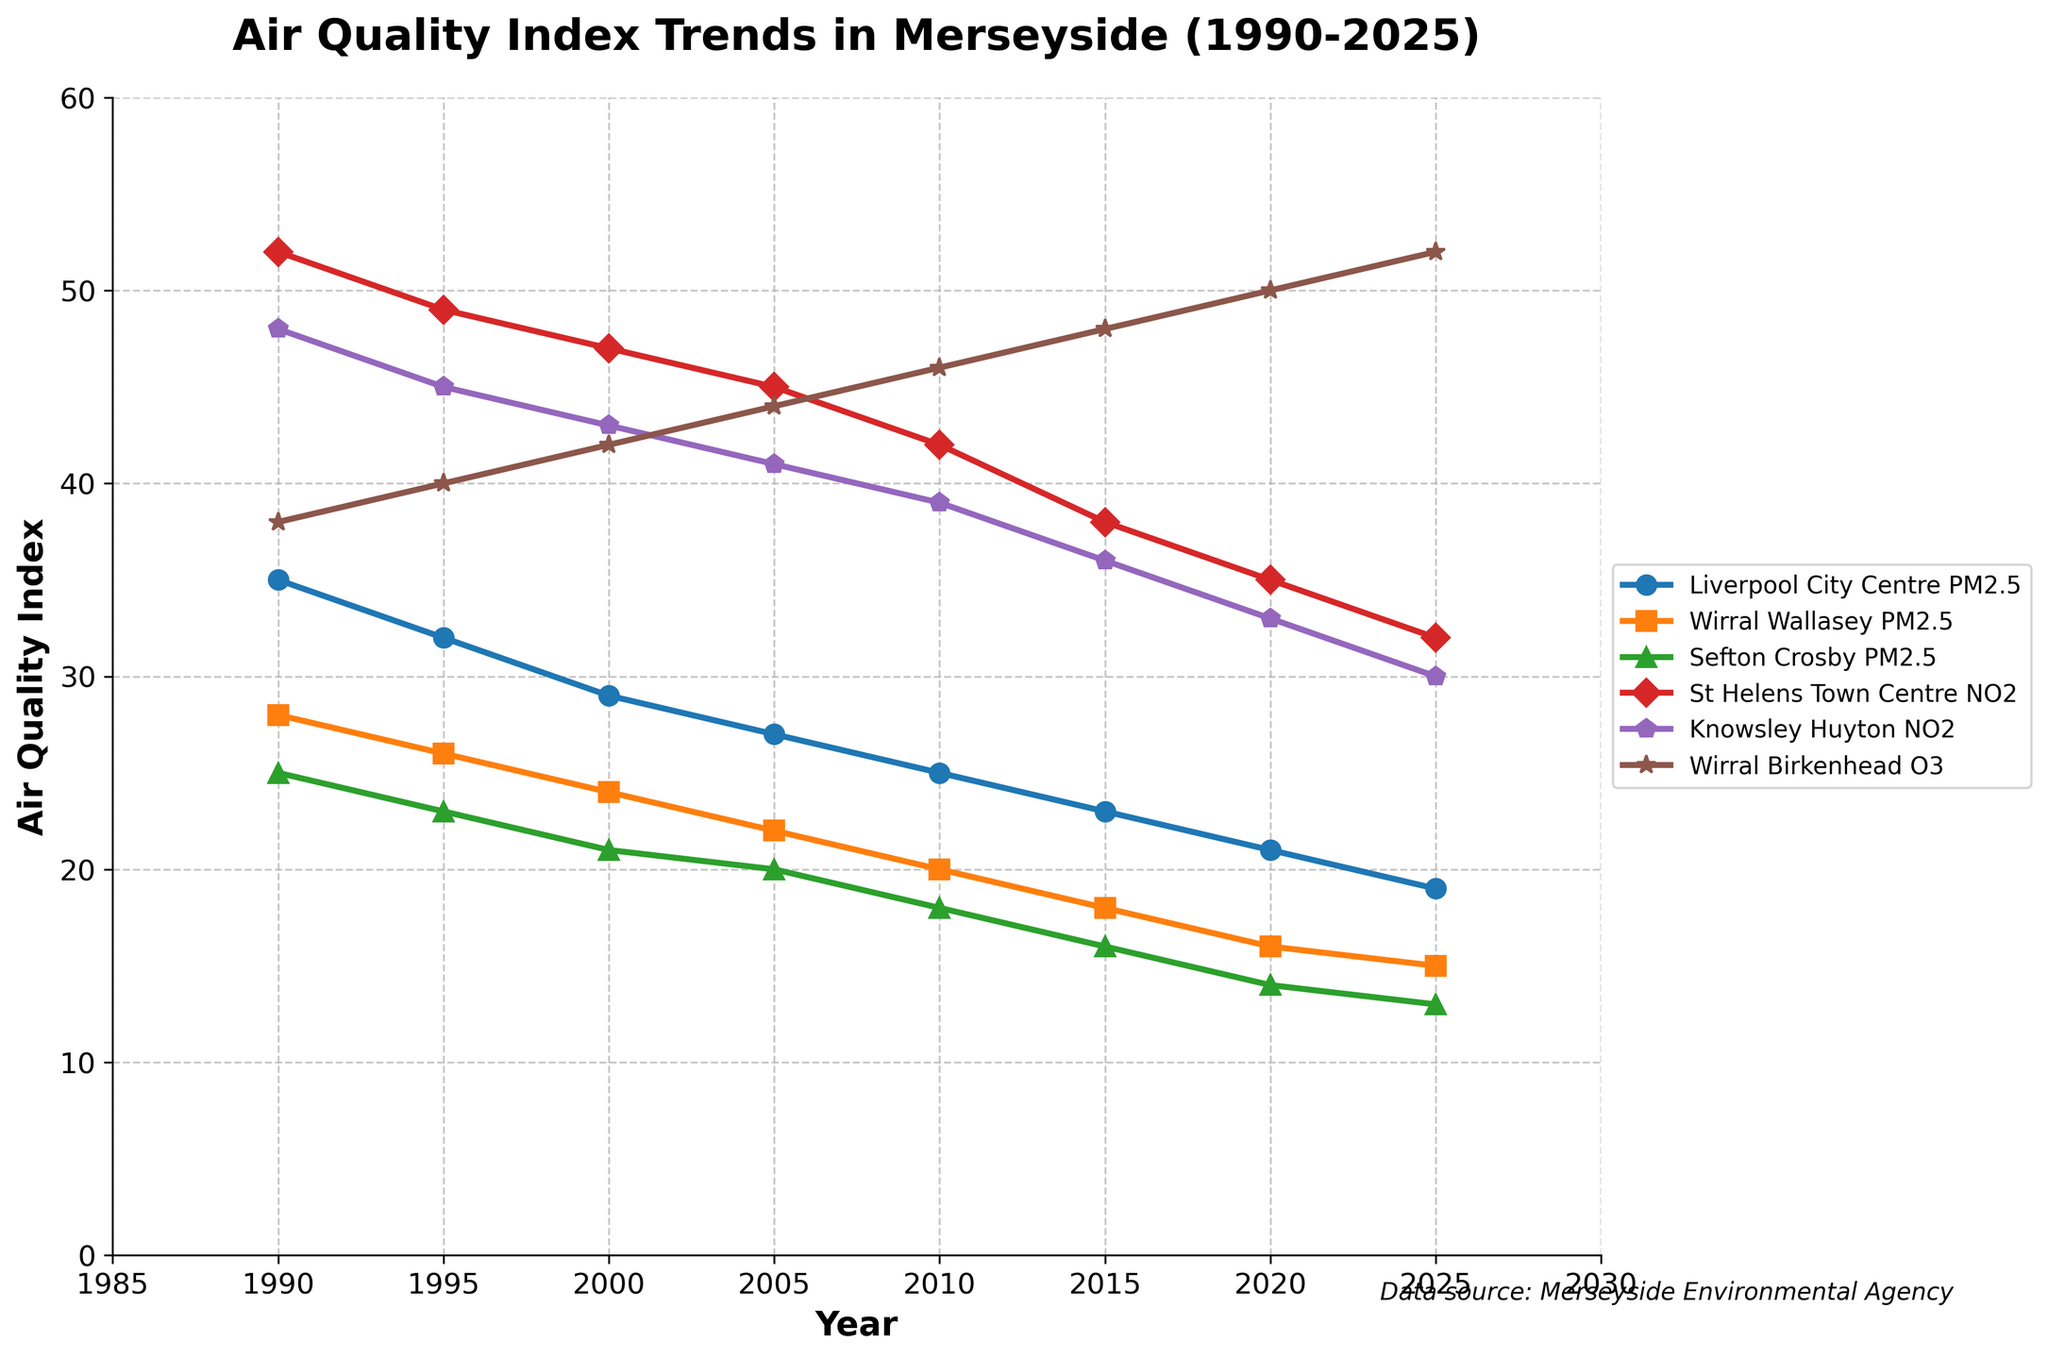What's the trend in Liverpool City Centre PM2.5 levels over the period? The data from the figure shows that the PM2.5 levels in Liverpool City Centre decrease steadily from 35 in 1990 to 19 in 2025. This indicates an overall improving trend in air quality for this region.
Answer: Decreasing trend How does the PM2.5 level in Sefton Crosby in 2025 compare to Wirral Wallasey in 1995? In 2025, the PM2.5 level in Sefton Crosby is 13, while in Wirral Wallasey in 1995, it was 26. Comparing these, the PM2.5 level in Sefton Crosby in 2025 is half of the level in Wirral Wallasey in 1995.
Answer: Lower Which area sees the greatest decrease in NO2 levels from 1990 to 2025? St Helens Town Centre NO2 levels decrease from 52 in 1990 to 32 in 2025, a difference of 20. Knowsley Huyton NO2 levels decrease from 48 to 30, a difference of 18. St Helens Town Centre sees the greatest decrease.
Answer: St Helens Town Centre What's the average PM2.5 level in Liverpool City Centre during the 2000s (2000 to 2025)? Add the values from 2000 to 2025: 29 + 27 + 25 + 23 + 21 + 19 = 144. Divide by the number of data points (6): 144 / 6 = 24
Answer: 24 In which year do Knowsley Huyton and Wirral Birkenhead have the closest values for their respective pollutants? Checking values for each year: 
- 1990: 48 (Knowsley Huyton NO2) vs. 38 (Wirral Birkenhead O3) = 10
- 1995: 45 vs. 40 = 5
- 2000: 43 vs. 42 = 1
- 2005: 41 vs. 44 = 3
- 2010: 39 vs. 46 = 7
- 2015: 36 vs. 48 = 12
- 2020: 33 vs. 50 = 17
- 2025: 30 vs. 52 = 22
The closest value difference is in 2000, with a difference of only 1.
Answer: 2000 